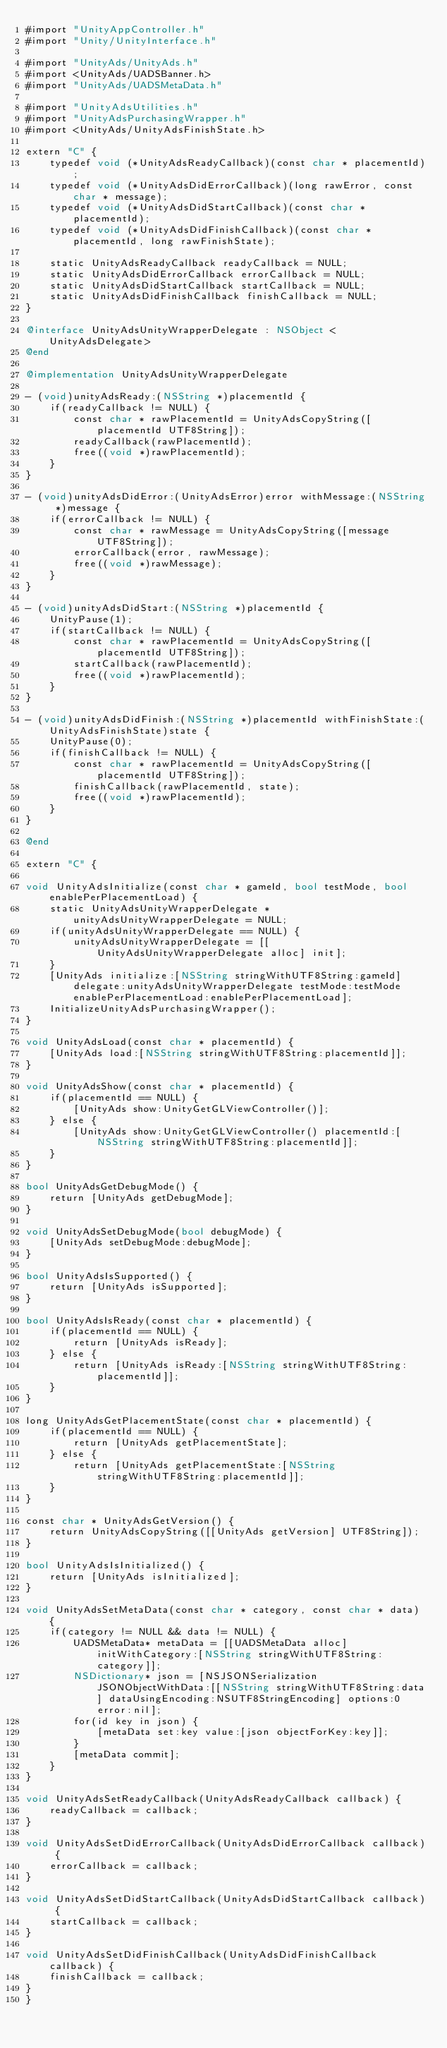<code> <loc_0><loc_0><loc_500><loc_500><_ObjectiveC_>#import "UnityAppController.h"
#import "Unity/UnityInterface.h"

#import "UnityAds/UnityAds.h"
#import <UnityAds/UADSBanner.h>
#import "UnityAds/UADSMetaData.h"

#import "UnityAdsUtilities.h"
#import "UnityAdsPurchasingWrapper.h"
#import <UnityAds/UnityAdsFinishState.h>

extern "C" {
    typedef void (*UnityAdsReadyCallback)(const char * placementId);
    typedef void (*UnityAdsDidErrorCallback)(long rawError, const char * message);
    typedef void (*UnityAdsDidStartCallback)(const char * placementId);
    typedef void (*UnityAdsDidFinishCallback)(const char * placementId, long rawFinishState);

    static UnityAdsReadyCallback readyCallback = NULL;
    static UnityAdsDidErrorCallback errorCallback = NULL;
    static UnityAdsDidStartCallback startCallback = NULL;
    static UnityAdsDidFinishCallback finishCallback = NULL;
}

@interface UnityAdsUnityWrapperDelegate : NSObject <UnityAdsDelegate>
@end

@implementation UnityAdsUnityWrapperDelegate

- (void)unityAdsReady:(NSString *)placementId {
    if(readyCallback != NULL) {
        const char * rawPlacementId = UnityAdsCopyString([placementId UTF8String]);
        readyCallback(rawPlacementId);
        free((void *)rawPlacementId);
    }
}

- (void)unityAdsDidError:(UnityAdsError)error withMessage:(NSString *)message {
    if(errorCallback != NULL) {
        const char * rawMessage = UnityAdsCopyString([message UTF8String]);
        errorCallback(error, rawMessage);
        free((void *)rawMessage);
    }
}

- (void)unityAdsDidStart:(NSString *)placementId {
    UnityPause(1);
    if(startCallback != NULL) {
        const char * rawPlacementId = UnityAdsCopyString([placementId UTF8String]);
        startCallback(rawPlacementId);
        free((void *)rawPlacementId);
    }
}

- (void)unityAdsDidFinish:(NSString *)placementId withFinishState:(UnityAdsFinishState)state {
    UnityPause(0);
    if(finishCallback != NULL) {
        const char * rawPlacementId = UnityAdsCopyString([placementId UTF8String]);
        finishCallback(rawPlacementId, state);
        free((void *)rawPlacementId);
    }
}

@end

extern "C" {

void UnityAdsInitialize(const char * gameId, bool testMode, bool enablePerPlacementLoad) {
    static UnityAdsUnityWrapperDelegate * unityAdsUnityWrapperDelegate = NULL;
    if(unityAdsUnityWrapperDelegate == NULL) {
        unityAdsUnityWrapperDelegate = [[UnityAdsUnityWrapperDelegate alloc] init];
    }
    [UnityAds initialize:[NSString stringWithUTF8String:gameId] delegate:unityAdsUnityWrapperDelegate testMode:testMode enablePerPlacementLoad:enablePerPlacementLoad];
    InitializeUnityAdsPurchasingWrapper();
}

void UnityAdsLoad(const char * placementId) {
    [UnityAds load:[NSString stringWithUTF8String:placementId]];
}

void UnityAdsShow(const char * placementId) {
    if(placementId == NULL) {
        [UnityAds show:UnityGetGLViewController()];
    } else {
        [UnityAds show:UnityGetGLViewController() placementId:[NSString stringWithUTF8String:placementId]];
    }
}

bool UnityAdsGetDebugMode() {
    return [UnityAds getDebugMode];
}

void UnityAdsSetDebugMode(bool debugMode) {
    [UnityAds setDebugMode:debugMode];
}

bool UnityAdsIsSupported() {
    return [UnityAds isSupported];
}

bool UnityAdsIsReady(const char * placementId) {
    if(placementId == NULL) {
        return [UnityAds isReady];
    } else {
        return [UnityAds isReady:[NSString stringWithUTF8String:placementId]];
    }
}

long UnityAdsGetPlacementState(const char * placementId) {
    if(placementId == NULL) {
        return [UnityAds getPlacementState];
    } else {
        return [UnityAds getPlacementState:[NSString stringWithUTF8String:placementId]];
    }
}

const char * UnityAdsGetVersion() {
    return UnityAdsCopyString([[UnityAds getVersion] UTF8String]);
}

bool UnityAdsIsInitialized() {
    return [UnityAds isInitialized];
}

void UnityAdsSetMetaData(const char * category, const char * data) {
    if(category != NULL && data != NULL) {
        UADSMetaData* metaData = [[UADSMetaData alloc] initWithCategory:[NSString stringWithUTF8String:category]];
        NSDictionary* json = [NSJSONSerialization JSONObjectWithData:[[NSString stringWithUTF8String:data] dataUsingEncoding:NSUTF8StringEncoding] options:0 error:nil];
        for(id key in json) {
            [metaData set:key value:[json objectForKey:key]];
        }
        [metaData commit];
    }
}

void UnityAdsSetReadyCallback(UnityAdsReadyCallback callback) {
    readyCallback = callback;
}

void UnityAdsSetDidErrorCallback(UnityAdsDidErrorCallback callback) {
    errorCallback = callback;
}

void UnityAdsSetDidStartCallback(UnityAdsDidStartCallback callback) {
    startCallback = callback;
}

void UnityAdsSetDidFinishCallback(UnityAdsDidFinishCallback callback) {
    finishCallback = callback;
}
}

</code> 